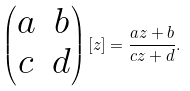<formula> <loc_0><loc_0><loc_500><loc_500>\begin{pmatrix} a & b \\ c & d \end{pmatrix} [ z ] = \frac { a z + b } { c z + d } .</formula> 